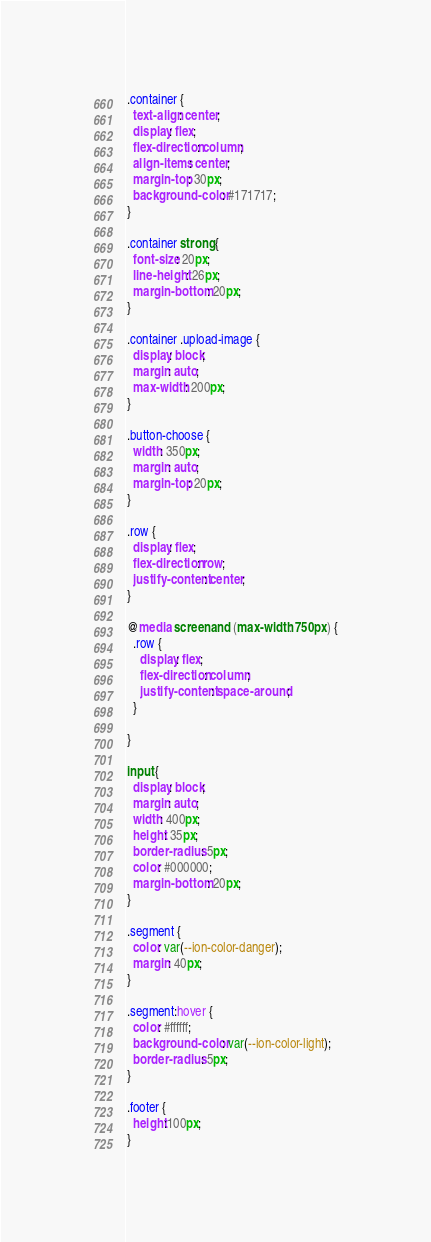Convert code to text. <code><loc_0><loc_0><loc_500><loc_500><_CSS_>.container {
  text-align: center;
  display: flex;
  flex-direction: column;
  align-items: center;
  margin-top: 30px;
  background-color: #171717;
}

.container strong {
  font-size: 20px;
  line-height: 26px;
  margin-bottom: 20px;
}

.container .upload-image {
  display: block;
  margin: auto;
  max-width: 200px; 
}

.button-choose {
  width: 350px;
  margin: auto;
  margin-top: 20px;
}

.row {
  display: flex;
  flex-direction: row;
  justify-content: center;
}

@media screen and (max-width: 750px) {
  .row {
    display: flex;
    flex-direction: column;
    justify-content: space-around;
  }

}

input {
  display: block;
  margin: auto;
  width: 400px;
  height: 35px;
  border-radius: 5px;
  color: #000000;
  margin-bottom: 20px;
}

.segment {
  color: var(--ion-color-danger);
  margin: 40px;
}

.segment:hover {
  color: #ffffff;
  background-color: var(--ion-color-light);
  border-radius: 5px;
}

.footer {
  height:100px;
}</code> 